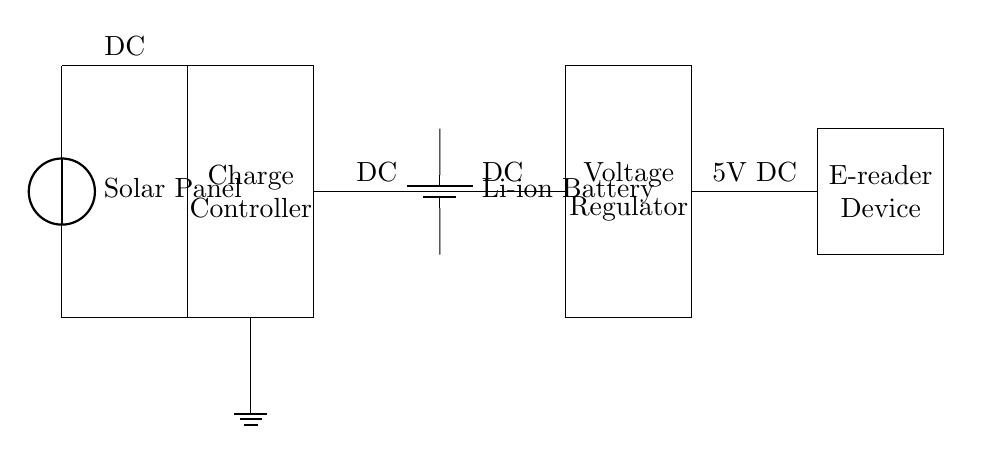What is the first component in the circuit? The first component in the circuit diagram is labeled as the Solar Panel, which is positioned at the top left.
Answer: Solar Panel What type of battery is used? The circuit shows a Li-ion battery labeled as the type used for energy storage. It is situated on the right of the charge controller.
Answer: Li-ion Battery What is the function of the charge controller? The charge controller regulates the voltage and current coming from the solar panel to ensure safe charging of the battery. Its role is vital in protecting the battery from overcharging.
Answer: Regulates charging What is the output voltage of the e-reader device? The e-reader device is indicated to operate at 5V DC, shown at the end of the circuit connected to the voltage regulator.
Answer: 5V DC Explain the connection path from the solar panel to the e-reader device. The connection path starts from the solar panel at the top left, which connects to the charge controller, then goes to the Li-ion battery, next to the voltage regulator, and finally reaches the e-reader device. Each component is connected sequentially to facilitate power flow.
Answer: Solar panel → charge controller → battery → voltage regulator → e-reader Why is a voltage regulator necessary in this circuit? The voltage regulator is essential to ensure that the e-reader device receives a consistent and appropriate voltage (5V DC) irrespective of fluctuations in the battery voltage, which may occur due to varying solar conditions. This ensures the safe operation of the e-reader device.
Answer: To provide consistent voltage 